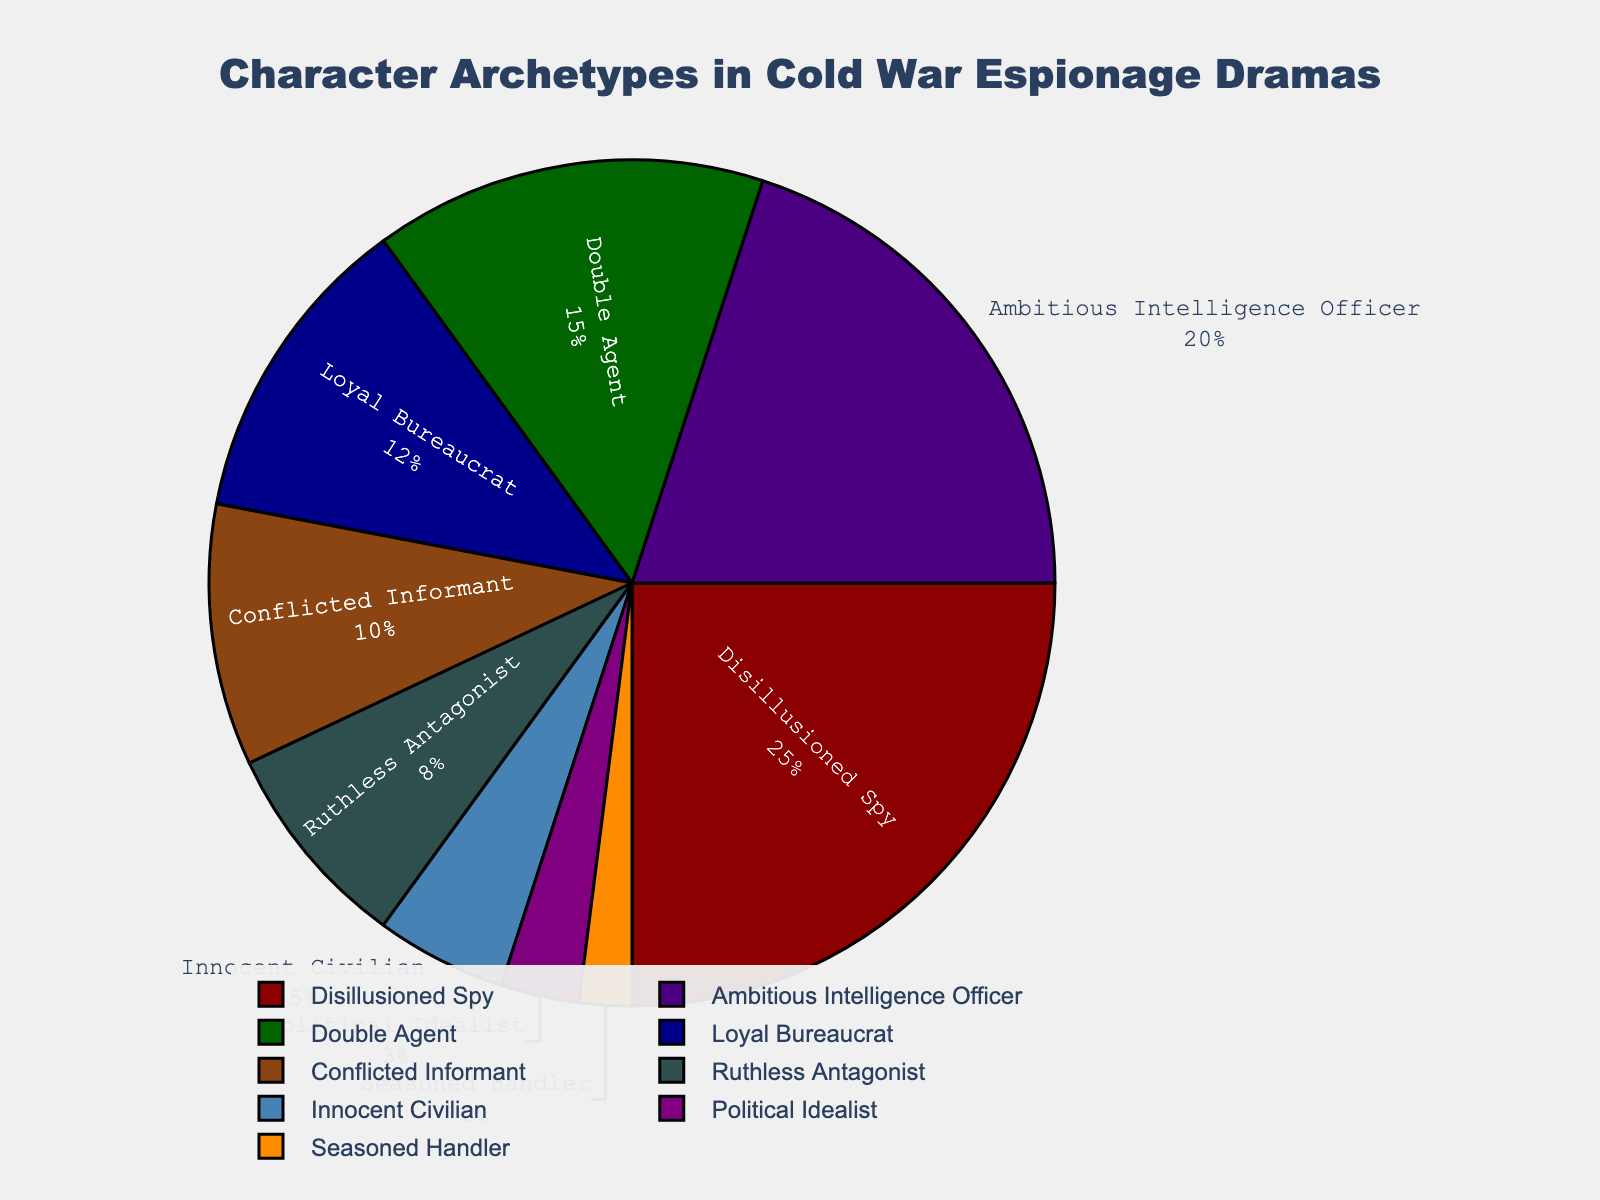Which character archetype has the highest percentage of screen time? By looking at the pie chart, the largest slice corresponds to the "Disillusioned Spy". This indicates that the "Disillusioned Spy" has the highest percentage of screen time.
Answer: Disillusioned Spy How much more percentage of screen time does the Ambitious Intelligence Officer have than the Loyal Bureaucrat? The Ambitious Intelligence Officer has 20% screen time, and the Loyal Bureaucrat has 12%. Subtracting these, 20% - 12% = 8%.
Answer: 8% What is the combined screen time percentage of the Double Agent and the Ruthless Antagonist? The Double Agent has 15% and the Ruthless Antagonist has 8%. Adding these together, 15% + 8% = 23%.
Answer: 23% Which character archetypes have less than 10% screen time? By referring to the pie chart, the archetypes with less than 10% screen time are the "Ruthless Antagonist" (8%), "Innocent Civilian" (5%), "Political Idealist" (3%), and "Seasoned Handler" (2%).
Answer: Ruthless Antagonist, Innocent Civilian, Political Idealist, Seasoned Handler Is the screen time of the Conflicted Informant greater than that of the Political Idealist? The Conflicted Informant has 10% screen time, while the Political Idealist has 3%. Since 10% > 3%, the screen time of the Conflicted Informant is greater.
Answer: Yes What is the average percentage of screen time allocated to the Innocent Civilian, Political Idealist, and Seasoned Handler? Adding the percentages of these three archetypes gives us 5% + 3% + 2% = 10%. Dividing by 3, the average percentage is 10% / 3 ≈ 3.33%.
Answer: 3.33% Which two character archetypes together make up the smallest portion of the screen time? The "Seasoned Handler" (2%) and "Political Idealist" (3%) have the smallest individual percentages. Together, they make up 2% + 3% = 5% screen time.
Answer: Seasoned Handler and Political Idealist How does the screen time of the most prominent archetype compare to the least prominent one? The most prominent archetype is the "Disillusioned Spy" with 25%, and the least prominent is the "Seasoned Handler" with 2%. The "Disillusioned Spy" has 25% - 2% = 23% more screen time than the "Seasoned Handler".
Answer: 23% more What is the sum of the screen time percentages for the top three character archetypes in the chart? The top three character archetypes are "Disillusioned Spy" (25%), "Ambitious Intelligence Officer" (20%), and "Double Agent" (15%). Adding these together, 25% + 20% + 15% = 60%.
Answer: 60% What percentage of screen time is taken by the characters with more than 10% each? The characters with more than 10% are "Disillusioned Spy" (25%), "Ambitious Intelligence Officer" (20%), "Double Agent" (15%), and "Loyal Bureaucrat" (12%). Adding these together, 25% + 20% + 15% + 12% = 72%.
Answer: 72% 